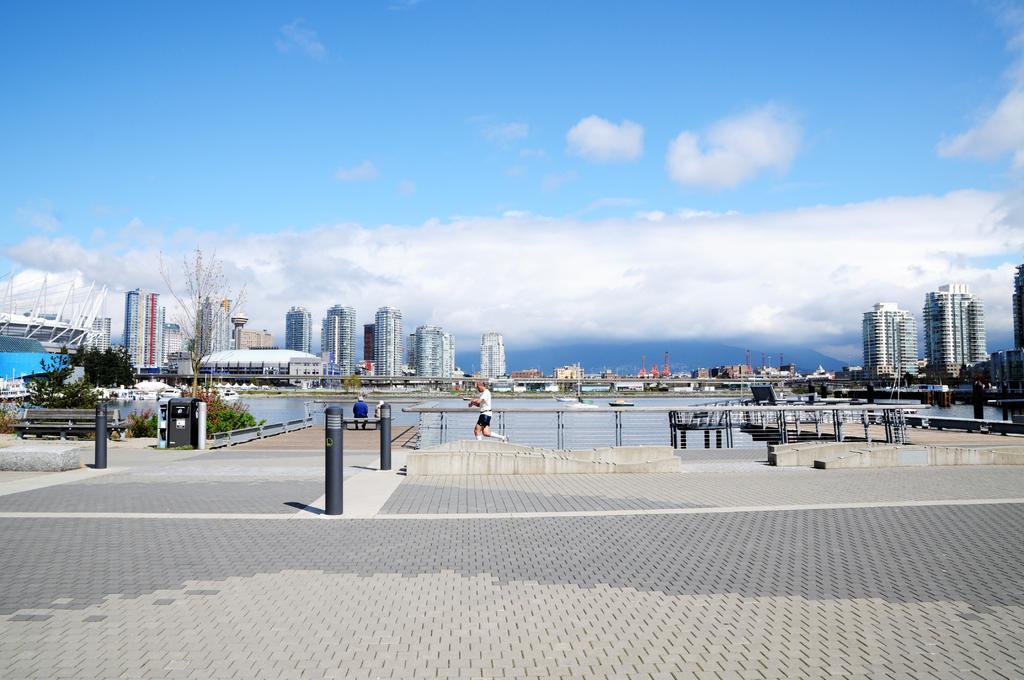How would you summarize this image in a sentence or two? In this picture we can see the cobbler stones in the front. Behind there is a river water. In the background we can see some buildings. On the top there is a sky and clouds. 